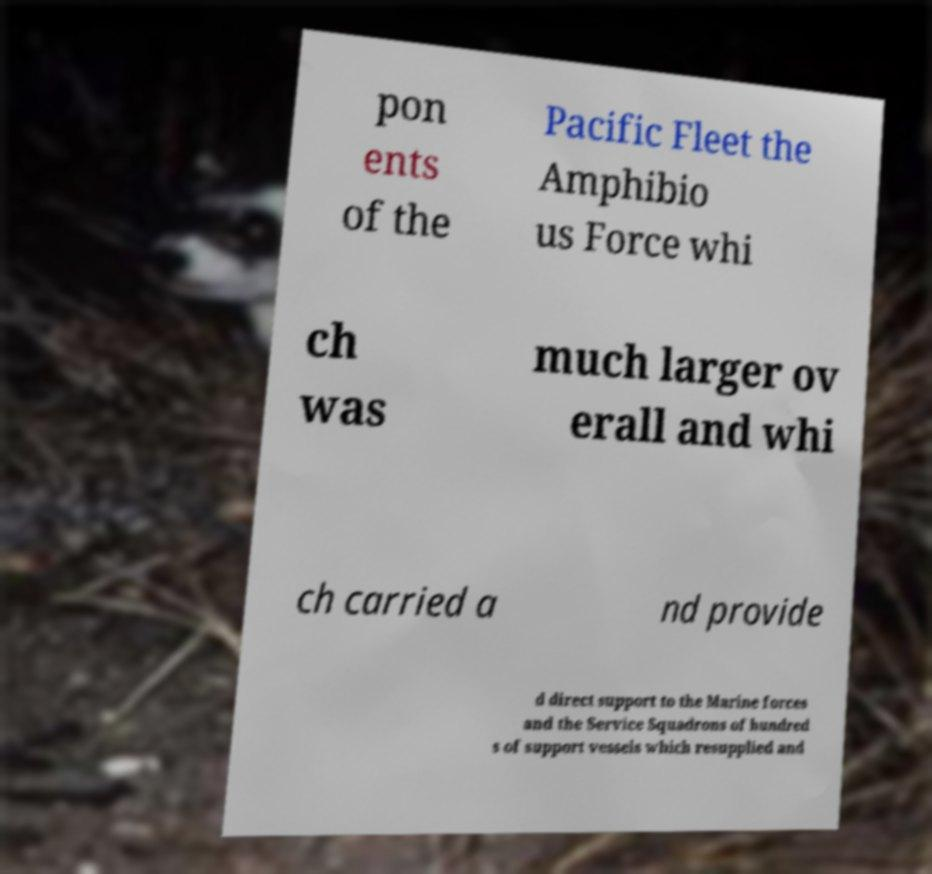Please read and relay the text visible in this image. What does it say? pon ents of the Pacific Fleet the Amphibio us Force whi ch was much larger ov erall and whi ch carried a nd provide d direct support to the Marine forces and the Service Squadrons of hundred s of support vessels which resupplied and 